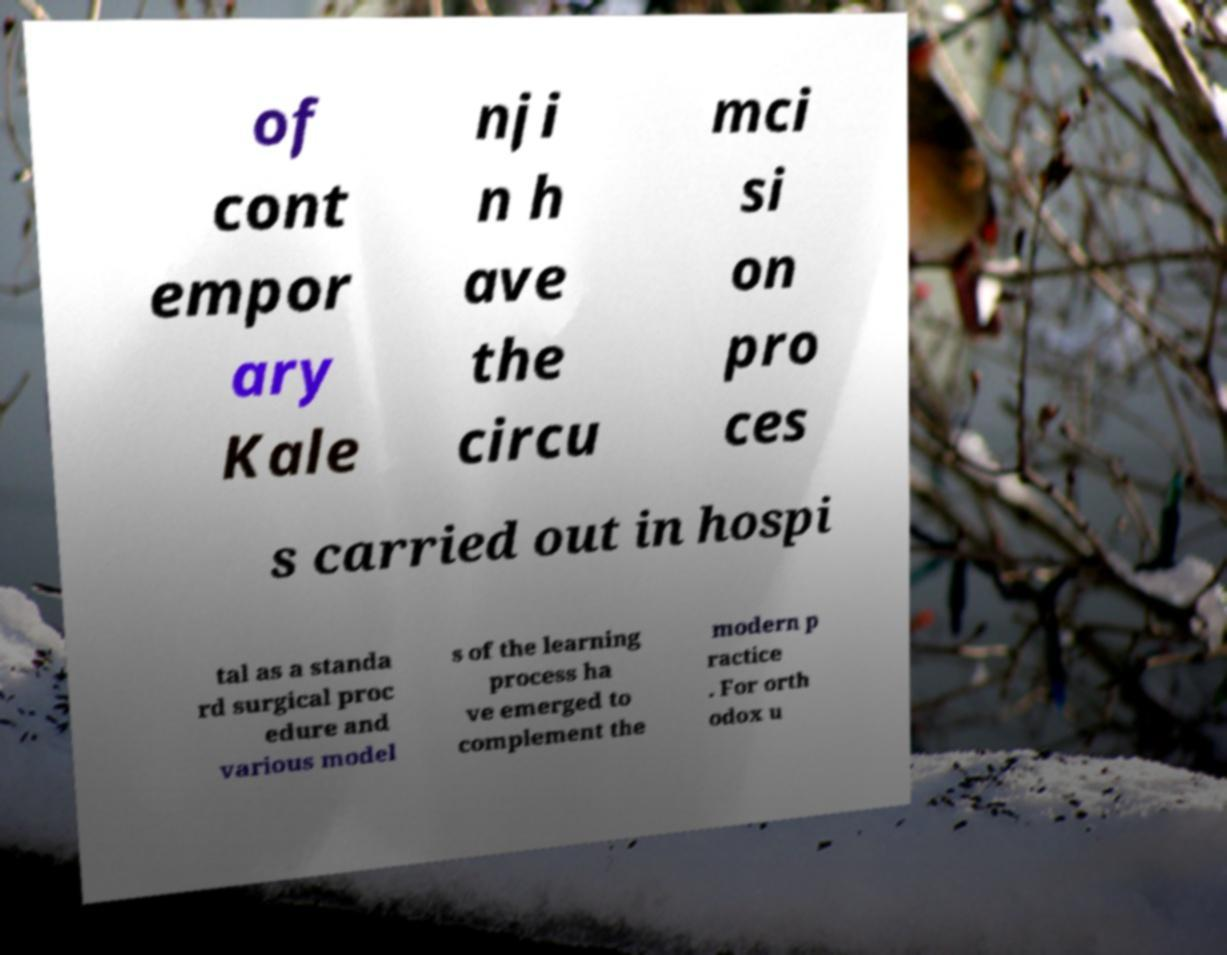Please identify and transcribe the text found in this image. of cont empor ary Kale nji n h ave the circu mci si on pro ces s carried out in hospi tal as a standa rd surgical proc edure and various model s of the learning process ha ve emerged to complement the modern p ractice . For orth odox u 